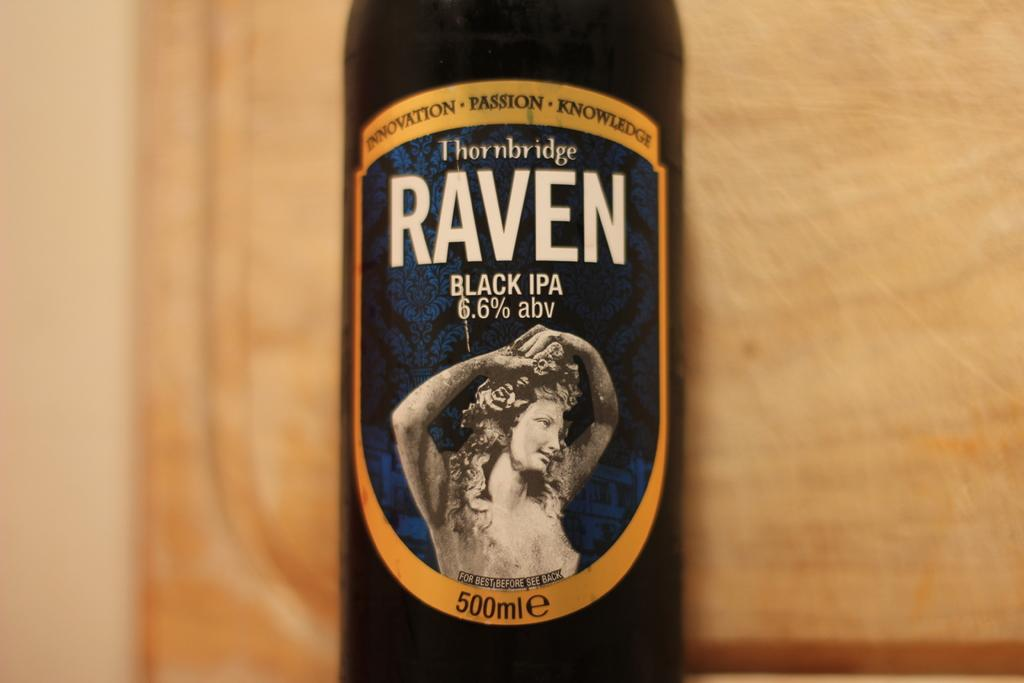<image>
Present a compact description of the photo's key features. A bottle of Thornbridge Raven Black IPA with a statue on the label. 